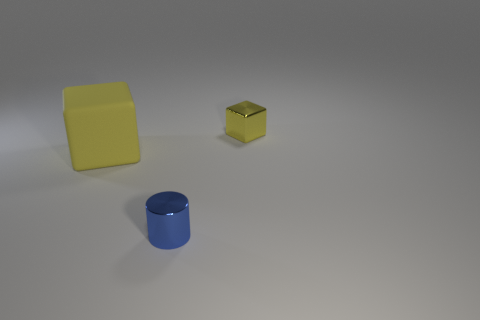Is the material of the large block the same as the tiny object in front of the small metal cube?
Your answer should be compact. No. There is another small object that is the same shape as the yellow rubber thing; what material is it?
Your answer should be very brief. Metal. Is there any other thing that is made of the same material as the large block?
Give a very brief answer. No. Is the material of the thing that is on the left side of the tiny blue object the same as the small thing that is in front of the tiny cube?
Ensure brevity in your answer.  No. The small object that is in front of the small thing right of the tiny thing on the left side of the yellow metallic block is what color?
Provide a short and direct response. Blue. What number of other things are there of the same shape as the large matte thing?
Provide a short and direct response. 1. Is the shiny cube the same color as the large rubber cube?
Provide a succinct answer. Yes. What number of objects are tiny blue shiny cylinders or small objects that are left of the small yellow shiny object?
Keep it short and to the point. 1. Is there a yellow cube of the same size as the blue shiny thing?
Provide a short and direct response. Yes. Is the small yellow cube made of the same material as the tiny blue thing?
Keep it short and to the point. Yes. 